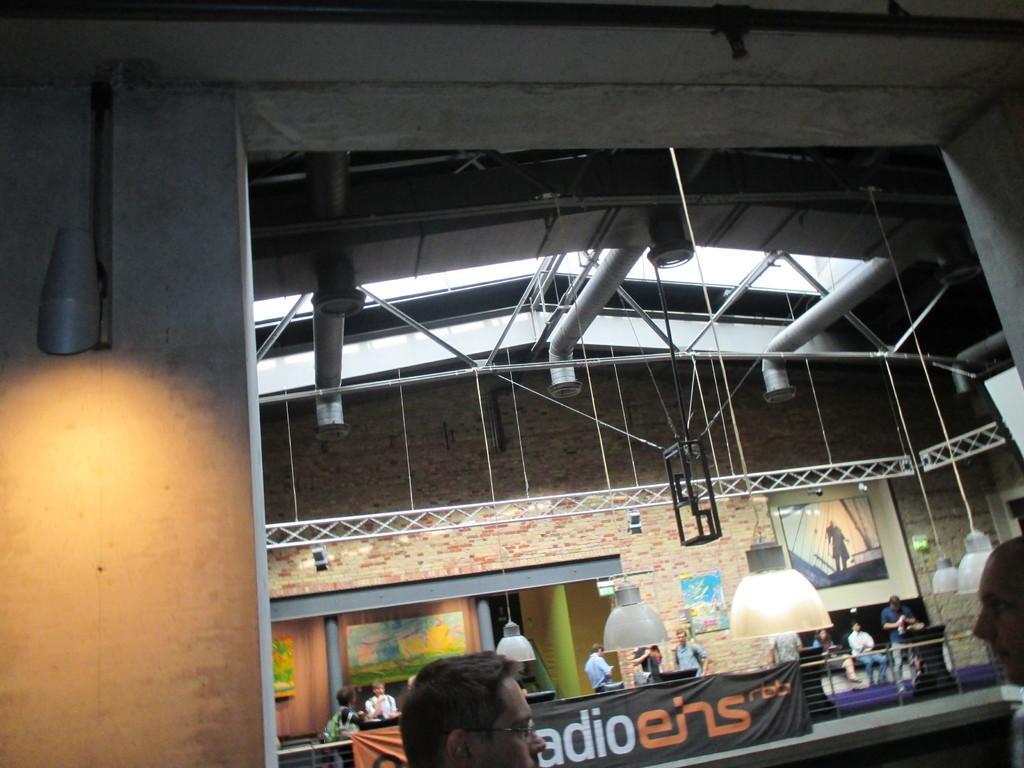Can you describe this image briefly? In this image we can see a group of people standing. In the background, we can see a group of poles a banner with some text, lights and a photo frame on the wall. 